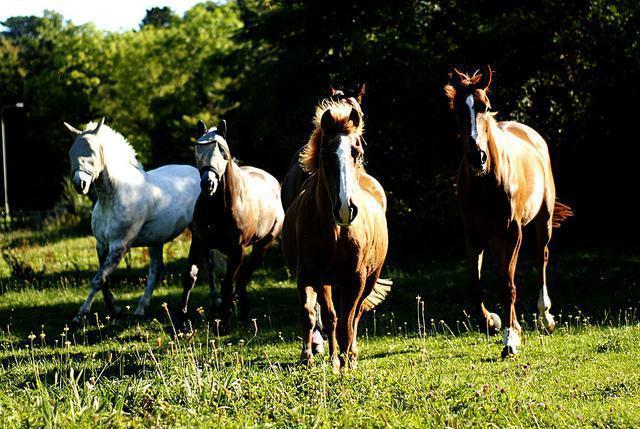These animals are known to do what?
Select the accurate response from the four choices given to answer the question.
Options: Hibernate, gallop, fly, swim. Gallop. 